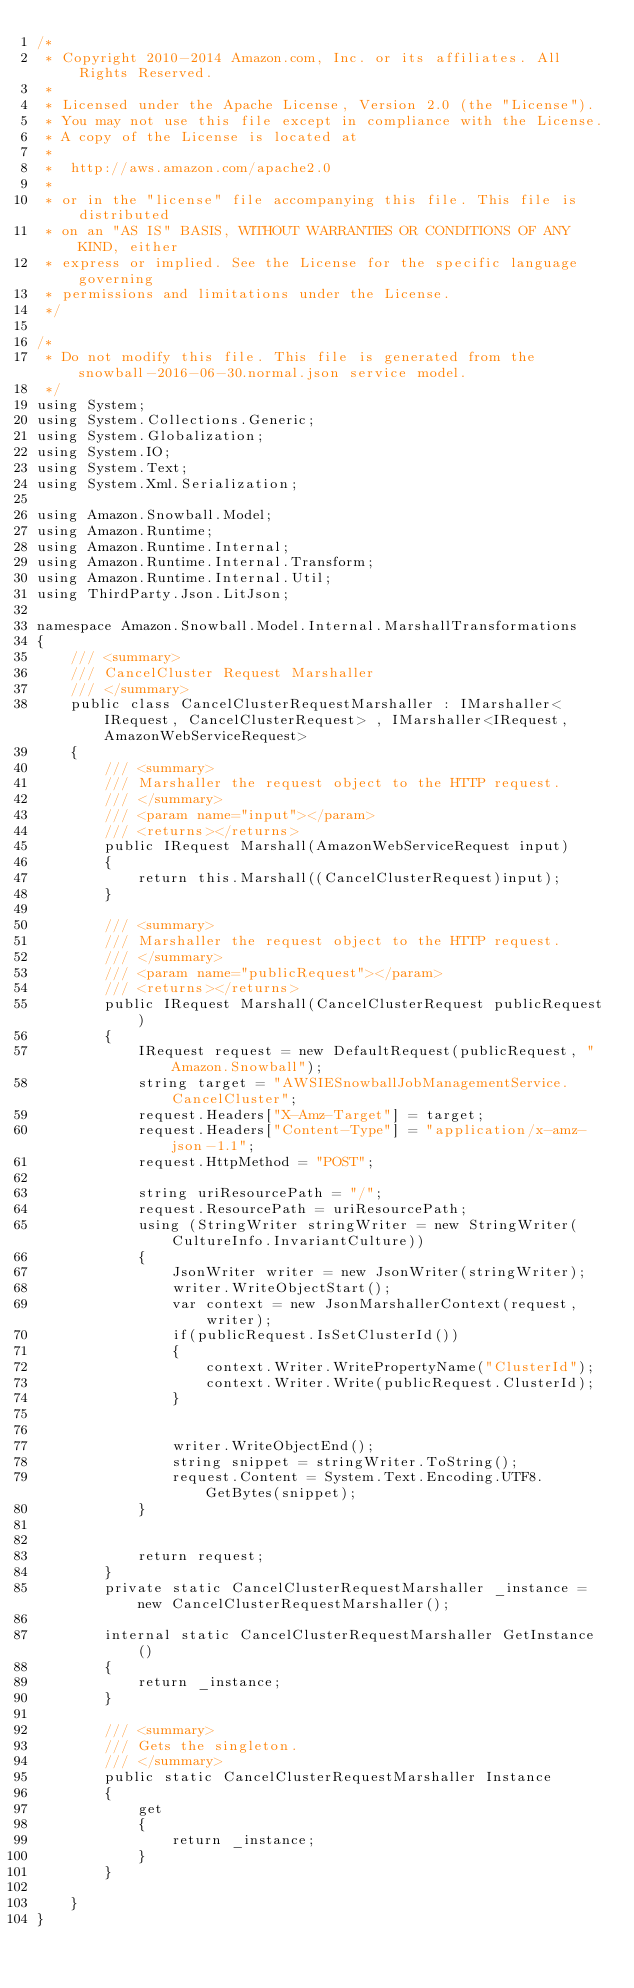<code> <loc_0><loc_0><loc_500><loc_500><_C#_>/*
 * Copyright 2010-2014 Amazon.com, Inc. or its affiliates. All Rights Reserved.
 * 
 * Licensed under the Apache License, Version 2.0 (the "License").
 * You may not use this file except in compliance with the License.
 * A copy of the License is located at
 * 
 *  http://aws.amazon.com/apache2.0
 * 
 * or in the "license" file accompanying this file. This file is distributed
 * on an "AS IS" BASIS, WITHOUT WARRANTIES OR CONDITIONS OF ANY KIND, either
 * express or implied. See the License for the specific language governing
 * permissions and limitations under the License.
 */

/*
 * Do not modify this file. This file is generated from the snowball-2016-06-30.normal.json service model.
 */
using System;
using System.Collections.Generic;
using System.Globalization;
using System.IO;
using System.Text;
using System.Xml.Serialization;

using Amazon.Snowball.Model;
using Amazon.Runtime;
using Amazon.Runtime.Internal;
using Amazon.Runtime.Internal.Transform;
using Amazon.Runtime.Internal.Util;
using ThirdParty.Json.LitJson;

namespace Amazon.Snowball.Model.Internal.MarshallTransformations
{
    /// <summary>
    /// CancelCluster Request Marshaller
    /// </summary>       
    public class CancelClusterRequestMarshaller : IMarshaller<IRequest, CancelClusterRequest> , IMarshaller<IRequest,AmazonWebServiceRequest>
    {
        /// <summary>
        /// Marshaller the request object to the HTTP request.
        /// </summary>  
        /// <param name="input"></param>
        /// <returns></returns>
        public IRequest Marshall(AmazonWebServiceRequest input)
        {
            return this.Marshall((CancelClusterRequest)input);
        }

        /// <summary>
        /// Marshaller the request object to the HTTP request.
        /// </summary>  
        /// <param name="publicRequest"></param>
        /// <returns></returns>
        public IRequest Marshall(CancelClusterRequest publicRequest)
        {
            IRequest request = new DefaultRequest(publicRequest, "Amazon.Snowball");
            string target = "AWSIESnowballJobManagementService.CancelCluster";
            request.Headers["X-Amz-Target"] = target;
            request.Headers["Content-Type"] = "application/x-amz-json-1.1";
            request.HttpMethod = "POST";

            string uriResourcePath = "/";
            request.ResourcePath = uriResourcePath;
            using (StringWriter stringWriter = new StringWriter(CultureInfo.InvariantCulture))
            {
                JsonWriter writer = new JsonWriter(stringWriter);
                writer.WriteObjectStart();
                var context = new JsonMarshallerContext(request, writer);
                if(publicRequest.IsSetClusterId())
                {
                    context.Writer.WritePropertyName("ClusterId");
                    context.Writer.Write(publicRequest.ClusterId);
                }

        
                writer.WriteObjectEnd();
                string snippet = stringWriter.ToString();
                request.Content = System.Text.Encoding.UTF8.GetBytes(snippet);
            }


            return request;
        }
        private static CancelClusterRequestMarshaller _instance = new CancelClusterRequestMarshaller();        

        internal static CancelClusterRequestMarshaller GetInstance()
        {
            return _instance;
        }

        /// <summary>
        /// Gets the singleton.
        /// </summary>  
        public static CancelClusterRequestMarshaller Instance
        {
            get
            {
                return _instance;
            }
        }

    }
}</code> 